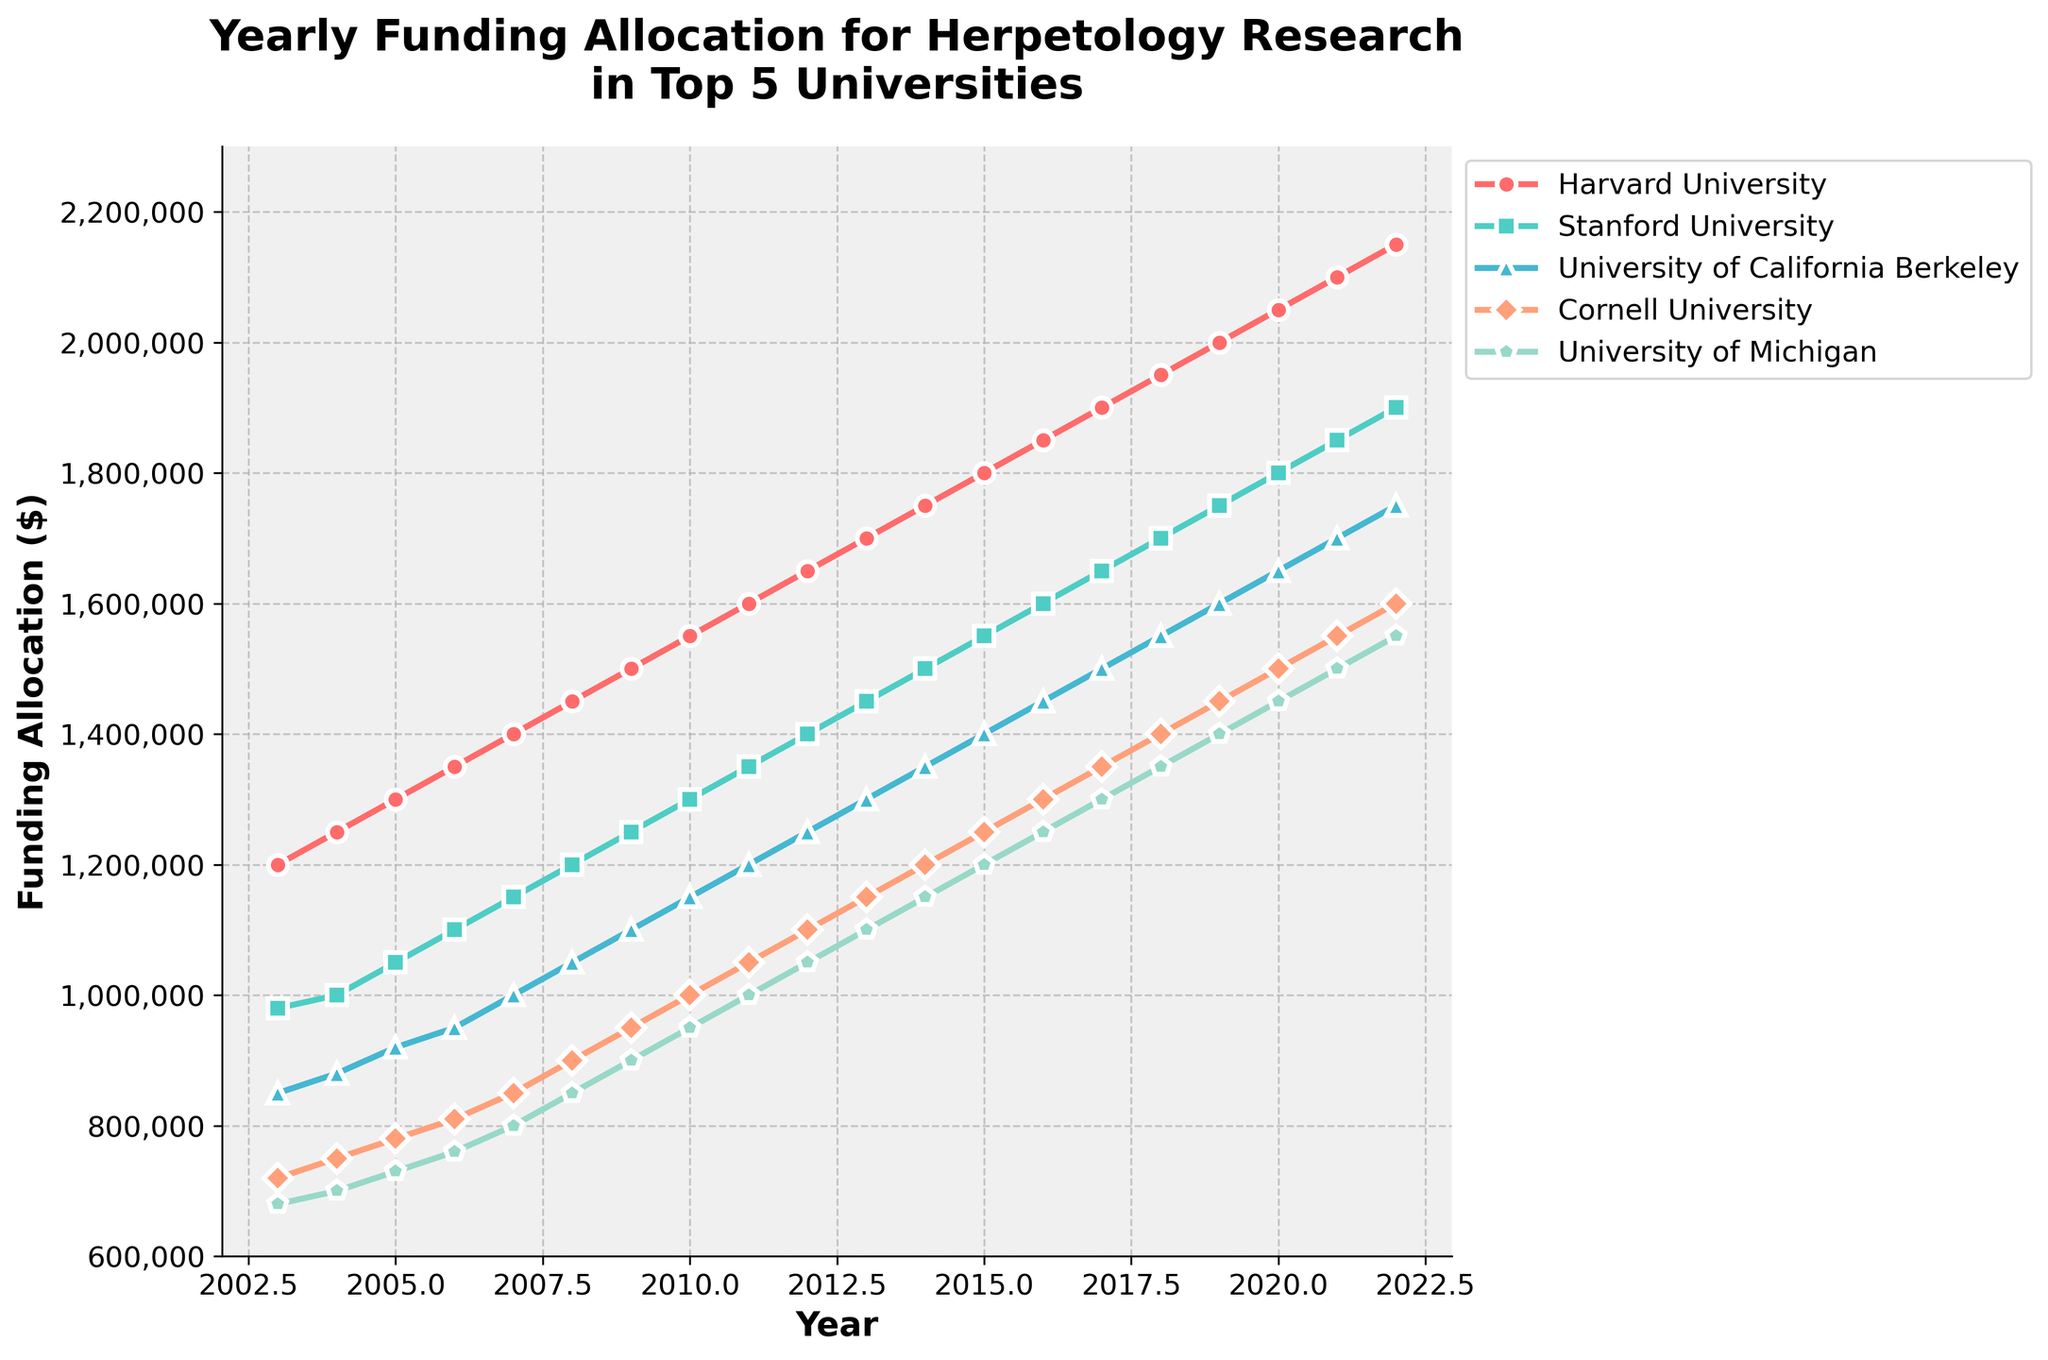Which university had the highest funding in 2020? To find the answer, look at the line corresponding to the year 2020 and identify the university with the highest data point on the y-axis.
Answer: Harvard University What is the difference in funding between Stanford University and University of Michigan in 2015? Locate the funding amounts for both universities in 2015. Subtract the amount allocated to the University of Michigan from the amount allocated to Stanford University.
Answer: $350,000 How has the funding trend for Cornell University changed from 2003 to 2022? Examine the line for Cornell University from 2003 to 2022, noting if the trend is increasing, decreasing, or remaining constant. Identify any significant fluctuations.
Answer: Increasing Which year did University of California Berkeley's funding exceed $1,500,000? Look at the line for the University of California Berkeley and determine the first year when the funding allocation surpassed $1,500,000.
Answer: 2017 Among the top 5 universities, which one had the lowest funding in 2008? Look at the values of all five universities in the year 2008 and identify the one with the smallest funding amount.
Answer: University of Michigan Which two universities showed the closest funding amounts in the year 2011? Compare the funding allocations for all five universities in 2011 and identify the two with the smallest difference in their amounts.
Answer: University of California Berkeley and Cornell University What was the average funding for the top 5 universities in 2019? Sum the funding allocations for all five universities in 2019 and divide by the number of universities (5).
Answer: $1,440,000 Did any university's funding ever decrease between successive years? Check the funding amounts for each university across all years and identify any instances where the funding amount in a particular year is less than the previous year.
Answer: No By how much did Harvard University's funding increase from 2003 to 2022? Subtract the funding amount in 2003 from the amount in 2022 for Harvard University.
Answer: $950,000 